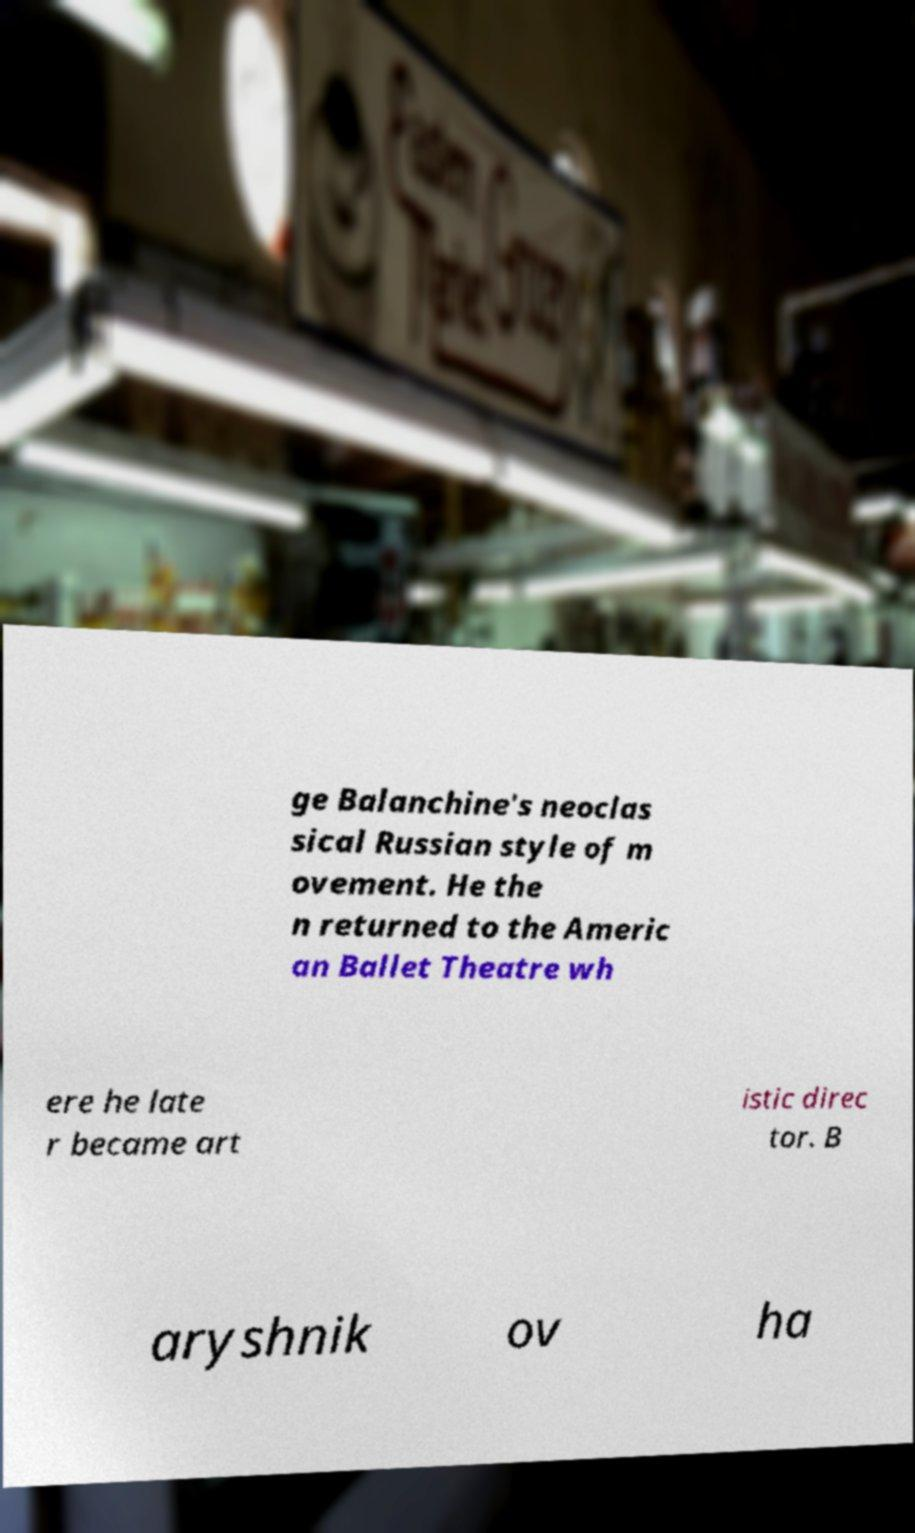For documentation purposes, I need the text within this image transcribed. Could you provide that? ge Balanchine's neoclas sical Russian style of m ovement. He the n returned to the Americ an Ballet Theatre wh ere he late r became art istic direc tor. B aryshnik ov ha 